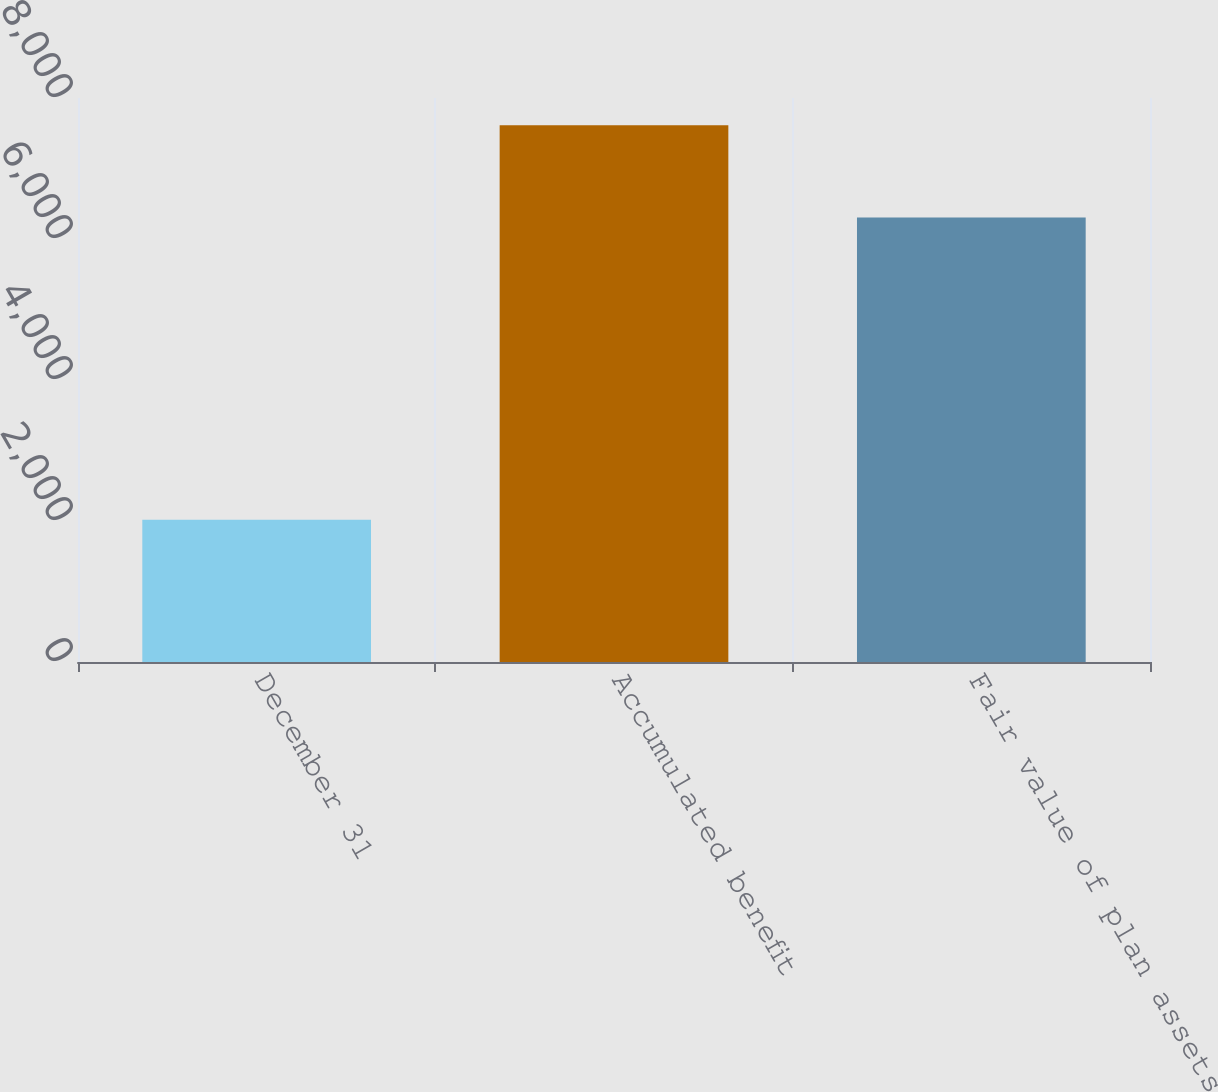Convert chart. <chart><loc_0><loc_0><loc_500><loc_500><bar_chart><fcel>December 31<fcel>Accumulated benefit<fcel>Fair value of plan assets<nl><fcel>2017<fcel>7614<fcel>6305<nl></chart> 